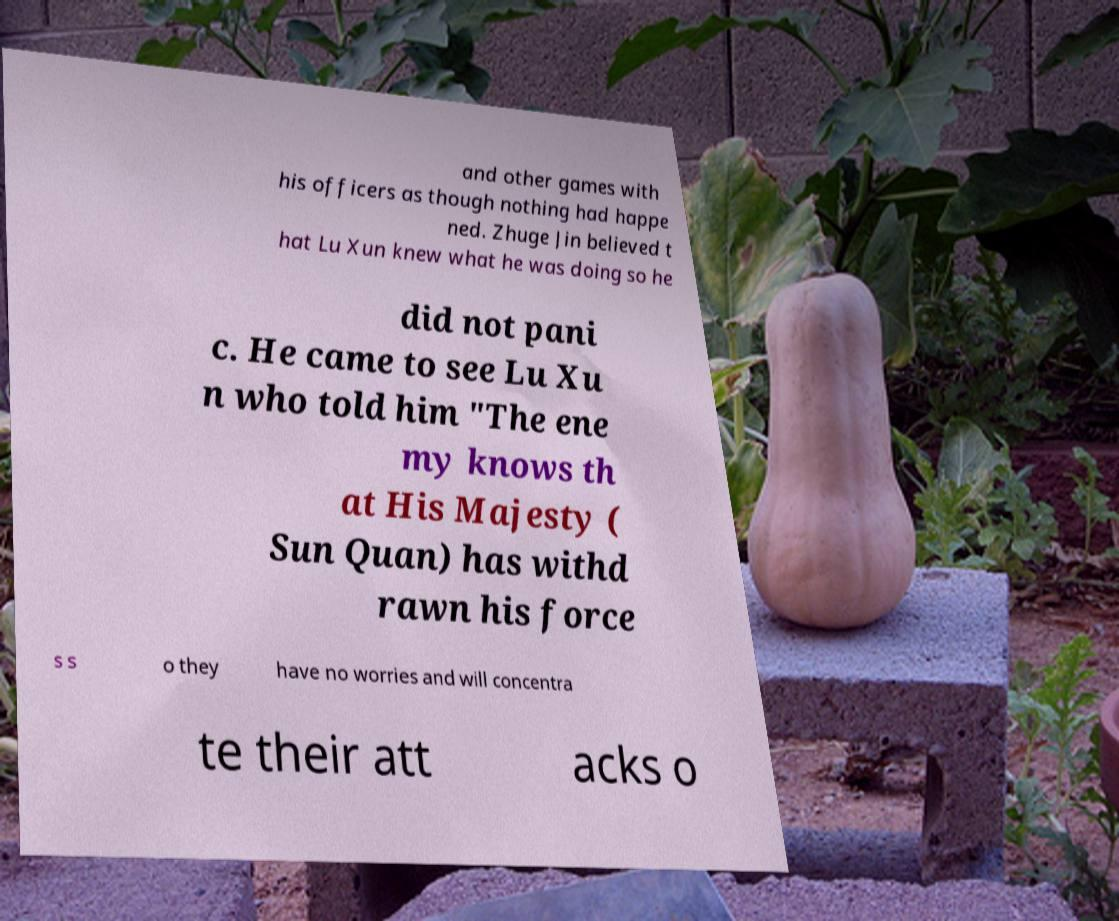Please identify and transcribe the text found in this image. and other games with his officers as though nothing had happe ned. Zhuge Jin believed t hat Lu Xun knew what he was doing so he did not pani c. He came to see Lu Xu n who told him "The ene my knows th at His Majesty ( Sun Quan) has withd rawn his force s s o they have no worries and will concentra te their att acks o 